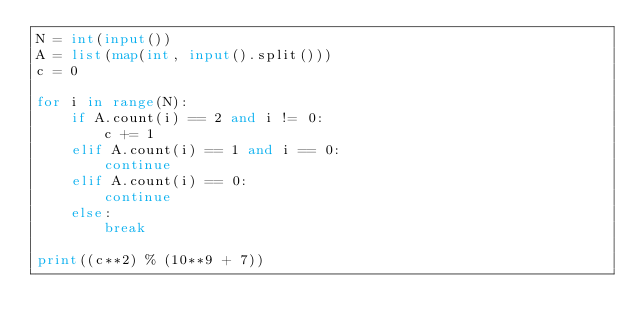Convert code to text. <code><loc_0><loc_0><loc_500><loc_500><_Python_>N = int(input())
A = list(map(int, input().split()))
c = 0

for i in range(N):
    if A.count(i) == 2 and i != 0:
        c += 1
    elif A.count(i) == 1 and i == 0:
        continue
    elif A.count(i) == 0:
        continue
    else:
        break
    
print((c**2) % (10**9 + 7))</code> 